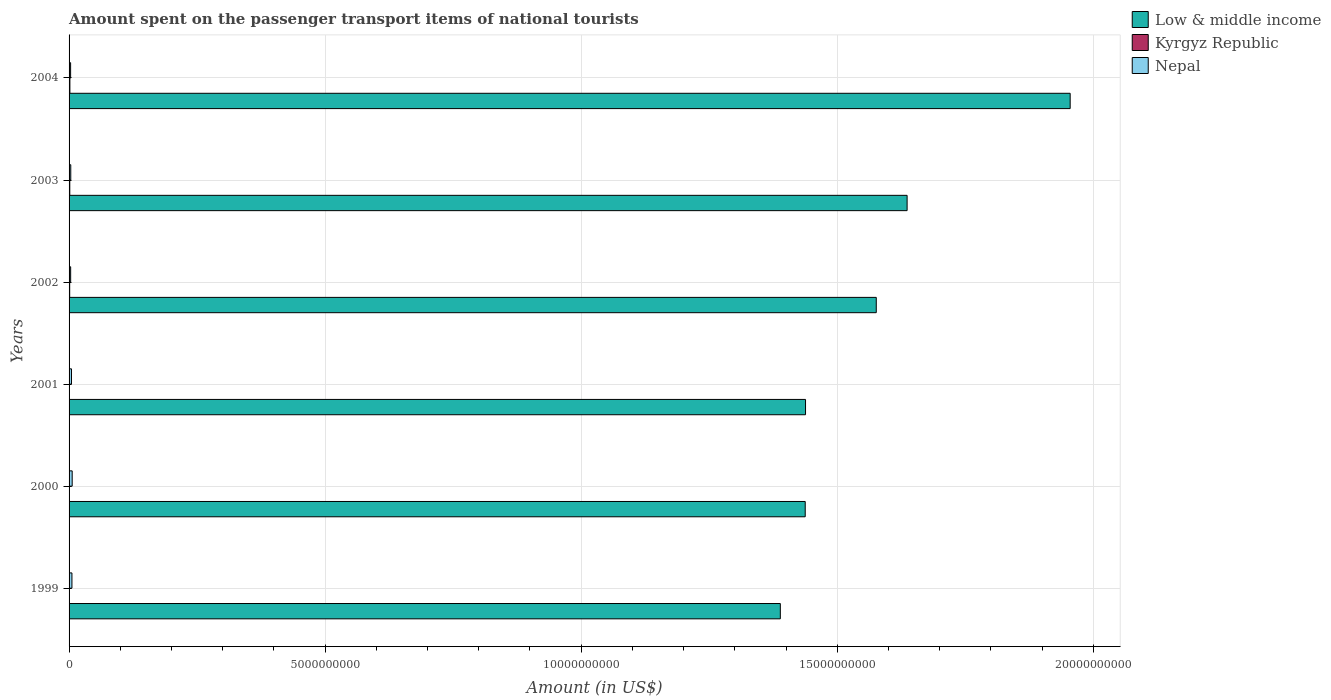How many different coloured bars are there?
Offer a very short reply. 3. How many groups of bars are there?
Provide a short and direct response. 6. Are the number of bars on each tick of the Y-axis equal?
Offer a very short reply. Yes. How many bars are there on the 6th tick from the top?
Your answer should be compact. 3. What is the amount spent on the passenger transport items of national tourists in Low & middle income in 2004?
Give a very brief answer. 1.95e+1. Across all years, what is the maximum amount spent on the passenger transport items of national tourists in Kyrgyz Republic?
Make the answer very short. 1.60e+07. Across all years, what is the minimum amount spent on the passenger transport items of national tourists in Low & middle income?
Make the answer very short. 1.39e+1. What is the total amount spent on the passenger transport items of national tourists in Nepal in the graph?
Your answer should be compact. 2.58e+08. What is the difference between the amount spent on the passenger transport items of national tourists in Kyrgyz Republic in 2000 and the amount spent on the passenger transport items of national tourists in Nepal in 2003?
Offer a terse response. -2.80e+07. What is the average amount spent on the passenger transport items of national tourists in Kyrgyz Republic per year?
Your answer should be compact. 9.83e+06. In the year 2000, what is the difference between the amount spent on the passenger transport items of national tourists in Kyrgyz Republic and amount spent on the passenger transport items of national tourists in Nepal?
Offer a terse response. -5.60e+07. What is the ratio of the amount spent on the passenger transport items of national tourists in Kyrgyz Republic in 2002 to that in 2003?
Give a very brief answer. 0.86. Is the amount spent on the passenger transport items of national tourists in Nepal in 1999 less than that in 2004?
Keep it short and to the point. No. Is the difference between the amount spent on the passenger transport items of national tourists in Kyrgyz Republic in 2002 and 2004 greater than the difference between the amount spent on the passenger transport items of national tourists in Nepal in 2002 and 2004?
Keep it short and to the point. No. What is the difference between the highest and the second highest amount spent on the passenger transport items of national tourists in Low & middle income?
Your response must be concise. 3.18e+09. In how many years, is the amount spent on the passenger transport items of national tourists in Nepal greater than the average amount spent on the passenger transport items of national tourists in Nepal taken over all years?
Your response must be concise. 3. What does the 3rd bar from the bottom in 1999 represents?
Give a very brief answer. Nepal. How many years are there in the graph?
Offer a very short reply. 6. Does the graph contain any zero values?
Provide a succinct answer. No. Does the graph contain grids?
Your answer should be compact. Yes. Where does the legend appear in the graph?
Ensure brevity in your answer.  Top right. How many legend labels are there?
Keep it short and to the point. 3. What is the title of the graph?
Provide a succinct answer. Amount spent on the passenger transport items of national tourists. Does "Chile" appear as one of the legend labels in the graph?
Ensure brevity in your answer.  No. What is the label or title of the X-axis?
Provide a succinct answer. Amount (in US$). What is the label or title of the Y-axis?
Your answer should be very brief. Years. What is the Amount (in US$) in Low & middle income in 1999?
Your answer should be very brief. 1.39e+1. What is the Amount (in US$) in Nepal in 1999?
Your answer should be very brief. 5.60e+07. What is the Amount (in US$) of Low & middle income in 2000?
Ensure brevity in your answer.  1.44e+1. What is the Amount (in US$) of Kyrgyz Republic in 2000?
Keep it short and to the point. 5.00e+06. What is the Amount (in US$) of Nepal in 2000?
Your answer should be compact. 6.10e+07. What is the Amount (in US$) in Low & middle income in 2001?
Give a very brief answer. 1.44e+1. What is the Amount (in US$) in Kyrgyz Republic in 2001?
Provide a short and direct response. 8.00e+06. What is the Amount (in US$) in Nepal in 2001?
Ensure brevity in your answer.  4.70e+07. What is the Amount (in US$) of Low & middle income in 2002?
Make the answer very short. 1.58e+1. What is the Amount (in US$) of Nepal in 2002?
Provide a short and direct response. 3.10e+07. What is the Amount (in US$) of Low & middle income in 2003?
Offer a terse response. 1.64e+1. What is the Amount (in US$) of Kyrgyz Republic in 2003?
Ensure brevity in your answer.  1.40e+07. What is the Amount (in US$) of Nepal in 2003?
Provide a short and direct response. 3.30e+07. What is the Amount (in US$) in Low & middle income in 2004?
Provide a short and direct response. 1.95e+1. What is the Amount (in US$) in Kyrgyz Republic in 2004?
Provide a succinct answer. 1.60e+07. What is the Amount (in US$) in Nepal in 2004?
Keep it short and to the point. 3.00e+07. Across all years, what is the maximum Amount (in US$) of Low & middle income?
Your answer should be compact. 1.95e+1. Across all years, what is the maximum Amount (in US$) in Kyrgyz Republic?
Your response must be concise. 1.60e+07. Across all years, what is the maximum Amount (in US$) of Nepal?
Offer a very short reply. 6.10e+07. Across all years, what is the minimum Amount (in US$) in Low & middle income?
Give a very brief answer. 1.39e+1. Across all years, what is the minimum Amount (in US$) in Nepal?
Your response must be concise. 3.00e+07. What is the total Amount (in US$) of Low & middle income in the graph?
Provide a short and direct response. 9.43e+1. What is the total Amount (in US$) of Kyrgyz Republic in the graph?
Make the answer very short. 5.90e+07. What is the total Amount (in US$) in Nepal in the graph?
Ensure brevity in your answer.  2.58e+08. What is the difference between the Amount (in US$) in Low & middle income in 1999 and that in 2000?
Provide a short and direct response. -4.86e+08. What is the difference between the Amount (in US$) in Kyrgyz Republic in 1999 and that in 2000?
Your answer should be compact. -1.00e+06. What is the difference between the Amount (in US$) of Nepal in 1999 and that in 2000?
Offer a very short reply. -5.00e+06. What is the difference between the Amount (in US$) of Low & middle income in 1999 and that in 2001?
Provide a succinct answer. -4.92e+08. What is the difference between the Amount (in US$) in Kyrgyz Republic in 1999 and that in 2001?
Give a very brief answer. -4.00e+06. What is the difference between the Amount (in US$) of Nepal in 1999 and that in 2001?
Your answer should be very brief. 9.00e+06. What is the difference between the Amount (in US$) of Low & middle income in 1999 and that in 2002?
Keep it short and to the point. -1.87e+09. What is the difference between the Amount (in US$) in Kyrgyz Republic in 1999 and that in 2002?
Your response must be concise. -8.00e+06. What is the difference between the Amount (in US$) of Nepal in 1999 and that in 2002?
Ensure brevity in your answer.  2.50e+07. What is the difference between the Amount (in US$) of Low & middle income in 1999 and that in 2003?
Your answer should be compact. -2.48e+09. What is the difference between the Amount (in US$) of Kyrgyz Republic in 1999 and that in 2003?
Give a very brief answer. -1.00e+07. What is the difference between the Amount (in US$) in Nepal in 1999 and that in 2003?
Offer a terse response. 2.30e+07. What is the difference between the Amount (in US$) of Low & middle income in 1999 and that in 2004?
Your response must be concise. -5.66e+09. What is the difference between the Amount (in US$) of Kyrgyz Republic in 1999 and that in 2004?
Keep it short and to the point. -1.20e+07. What is the difference between the Amount (in US$) of Nepal in 1999 and that in 2004?
Offer a terse response. 2.60e+07. What is the difference between the Amount (in US$) of Low & middle income in 2000 and that in 2001?
Provide a short and direct response. -5.99e+06. What is the difference between the Amount (in US$) in Kyrgyz Republic in 2000 and that in 2001?
Your response must be concise. -3.00e+06. What is the difference between the Amount (in US$) in Nepal in 2000 and that in 2001?
Make the answer very short. 1.40e+07. What is the difference between the Amount (in US$) in Low & middle income in 2000 and that in 2002?
Your answer should be very brief. -1.39e+09. What is the difference between the Amount (in US$) of Kyrgyz Republic in 2000 and that in 2002?
Your answer should be very brief. -7.00e+06. What is the difference between the Amount (in US$) in Nepal in 2000 and that in 2002?
Make the answer very short. 3.00e+07. What is the difference between the Amount (in US$) of Low & middle income in 2000 and that in 2003?
Ensure brevity in your answer.  -1.99e+09. What is the difference between the Amount (in US$) in Kyrgyz Republic in 2000 and that in 2003?
Offer a very short reply. -9.00e+06. What is the difference between the Amount (in US$) in Nepal in 2000 and that in 2003?
Offer a terse response. 2.80e+07. What is the difference between the Amount (in US$) of Low & middle income in 2000 and that in 2004?
Make the answer very short. -5.17e+09. What is the difference between the Amount (in US$) of Kyrgyz Republic in 2000 and that in 2004?
Ensure brevity in your answer.  -1.10e+07. What is the difference between the Amount (in US$) of Nepal in 2000 and that in 2004?
Provide a short and direct response. 3.10e+07. What is the difference between the Amount (in US$) of Low & middle income in 2001 and that in 2002?
Your answer should be very brief. -1.38e+09. What is the difference between the Amount (in US$) in Nepal in 2001 and that in 2002?
Provide a succinct answer. 1.60e+07. What is the difference between the Amount (in US$) of Low & middle income in 2001 and that in 2003?
Provide a succinct answer. -1.98e+09. What is the difference between the Amount (in US$) in Kyrgyz Republic in 2001 and that in 2003?
Give a very brief answer. -6.00e+06. What is the difference between the Amount (in US$) of Nepal in 2001 and that in 2003?
Keep it short and to the point. 1.40e+07. What is the difference between the Amount (in US$) in Low & middle income in 2001 and that in 2004?
Provide a succinct answer. -5.17e+09. What is the difference between the Amount (in US$) in Kyrgyz Republic in 2001 and that in 2004?
Your response must be concise. -8.00e+06. What is the difference between the Amount (in US$) of Nepal in 2001 and that in 2004?
Your answer should be compact. 1.70e+07. What is the difference between the Amount (in US$) in Low & middle income in 2002 and that in 2003?
Keep it short and to the point. -6.02e+08. What is the difference between the Amount (in US$) in Kyrgyz Republic in 2002 and that in 2003?
Provide a short and direct response. -2.00e+06. What is the difference between the Amount (in US$) of Nepal in 2002 and that in 2003?
Provide a succinct answer. -2.00e+06. What is the difference between the Amount (in US$) of Low & middle income in 2002 and that in 2004?
Ensure brevity in your answer.  -3.79e+09. What is the difference between the Amount (in US$) in Kyrgyz Republic in 2002 and that in 2004?
Offer a terse response. -4.00e+06. What is the difference between the Amount (in US$) of Low & middle income in 2003 and that in 2004?
Make the answer very short. -3.18e+09. What is the difference between the Amount (in US$) of Kyrgyz Republic in 2003 and that in 2004?
Your answer should be very brief. -2.00e+06. What is the difference between the Amount (in US$) of Low & middle income in 1999 and the Amount (in US$) of Kyrgyz Republic in 2000?
Provide a succinct answer. 1.39e+1. What is the difference between the Amount (in US$) of Low & middle income in 1999 and the Amount (in US$) of Nepal in 2000?
Ensure brevity in your answer.  1.38e+1. What is the difference between the Amount (in US$) in Kyrgyz Republic in 1999 and the Amount (in US$) in Nepal in 2000?
Make the answer very short. -5.70e+07. What is the difference between the Amount (in US$) in Low & middle income in 1999 and the Amount (in US$) in Kyrgyz Republic in 2001?
Provide a succinct answer. 1.39e+1. What is the difference between the Amount (in US$) of Low & middle income in 1999 and the Amount (in US$) of Nepal in 2001?
Give a very brief answer. 1.38e+1. What is the difference between the Amount (in US$) of Kyrgyz Republic in 1999 and the Amount (in US$) of Nepal in 2001?
Keep it short and to the point. -4.30e+07. What is the difference between the Amount (in US$) in Low & middle income in 1999 and the Amount (in US$) in Kyrgyz Republic in 2002?
Give a very brief answer. 1.39e+1. What is the difference between the Amount (in US$) in Low & middle income in 1999 and the Amount (in US$) in Nepal in 2002?
Provide a short and direct response. 1.39e+1. What is the difference between the Amount (in US$) in Kyrgyz Republic in 1999 and the Amount (in US$) in Nepal in 2002?
Your answer should be very brief. -2.70e+07. What is the difference between the Amount (in US$) of Low & middle income in 1999 and the Amount (in US$) of Kyrgyz Republic in 2003?
Provide a short and direct response. 1.39e+1. What is the difference between the Amount (in US$) in Low & middle income in 1999 and the Amount (in US$) in Nepal in 2003?
Provide a succinct answer. 1.39e+1. What is the difference between the Amount (in US$) of Kyrgyz Republic in 1999 and the Amount (in US$) of Nepal in 2003?
Your response must be concise. -2.90e+07. What is the difference between the Amount (in US$) in Low & middle income in 1999 and the Amount (in US$) in Kyrgyz Republic in 2004?
Make the answer very short. 1.39e+1. What is the difference between the Amount (in US$) in Low & middle income in 1999 and the Amount (in US$) in Nepal in 2004?
Your answer should be very brief. 1.39e+1. What is the difference between the Amount (in US$) in Kyrgyz Republic in 1999 and the Amount (in US$) in Nepal in 2004?
Provide a short and direct response. -2.60e+07. What is the difference between the Amount (in US$) of Low & middle income in 2000 and the Amount (in US$) of Kyrgyz Republic in 2001?
Your answer should be compact. 1.44e+1. What is the difference between the Amount (in US$) in Low & middle income in 2000 and the Amount (in US$) in Nepal in 2001?
Offer a terse response. 1.43e+1. What is the difference between the Amount (in US$) of Kyrgyz Republic in 2000 and the Amount (in US$) of Nepal in 2001?
Your answer should be compact. -4.20e+07. What is the difference between the Amount (in US$) of Low & middle income in 2000 and the Amount (in US$) of Kyrgyz Republic in 2002?
Your answer should be compact. 1.44e+1. What is the difference between the Amount (in US$) of Low & middle income in 2000 and the Amount (in US$) of Nepal in 2002?
Make the answer very short. 1.43e+1. What is the difference between the Amount (in US$) of Kyrgyz Republic in 2000 and the Amount (in US$) of Nepal in 2002?
Make the answer very short. -2.60e+07. What is the difference between the Amount (in US$) of Low & middle income in 2000 and the Amount (in US$) of Kyrgyz Republic in 2003?
Offer a very short reply. 1.44e+1. What is the difference between the Amount (in US$) of Low & middle income in 2000 and the Amount (in US$) of Nepal in 2003?
Make the answer very short. 1.43e+1. What is the difference between the Amount (in US$) of Kyrgyz Republic in 2000 and the Amount (in US$) of Nepal in 2003?
Your answer should be very brief. -2.80e+07. What is the difference between the Amount (in US$) of Low & middle income in 2000 and the Amount (in US$) of Kyrgyz Republic in 2004?
Provide a short and direct response. 1.44e+1. What is the difference between the Amount (in US$) in Low & middle income in 2000 and the Amount (in US$) in Nepal in 2004?
Offer a terse response. 1.43e+1. What is the difference between the Amount (in US$) in Kyrgyz Republic in 2000 and the Amount (in US$) in Nepal in 2004?
Make the answer very short. -2.50e+07. What is the difference between the Amount (in US$) of Low & middle income in 2001 and the Amount (in US$) of Kyrgyz Republic in 2002?
Provide a succinct answer. 1.44e+1. What is the difference between the Amount (in US$) in Low & middle income in 2001 and the Amount (in US$) in Nepal in 2002?
Your response must be concise. 1.43e+1. What is the difference between the Amount (in US$) in Kyrgyz Republic in 2001 and the Amount (in US$) in Nepal in 2002?
Your response must be concise. -2.30e+07. What is the difference between the Amount (in US$) of Low & middle income in 2001 and the Amount (in US$) of Kyrgyz Republic in 2003?
Provide a succinct answer. 1.44e+1. What is the difference between the Amount (in US$) in Low & middle income in 2001 and the Amount (in US$) in Nepal in 2003?
Provide a succinct answer. 1.43e+1. What is the difference between the Amount (in US$) of Kyrgyz Republic in 2001 and the Amount (in US$) of Nepal in 2003?
Your answer should be compact. -2.50e+07. What is the difference between the Amount (in US$) in Low & middle income in 2001 and the Amount (in US$) in Kyrgyz Republic in 2004?
Make the answer very short. 1.44e+1. What is the difference between the Amount (in US$) of Low & middle income in 2001 and the Amount (in US$) of Nepal in 2004?
Provide a short and direct response. 1.44e+1. What is the difference between the Amount (in US$) of Kyrgyz Republic in 2001 and the Amount (in US$) of Nepal in 2004?
Make the answer very short. -2.20e+07. What is the difference between the Amount (in US$) of Low & middle income in 2002 and the Amount (in US$) of Kyrgyz Republic in 2003?
Your answer should be compact. 1.57e+1. What is the difference between the Amount (in US$) in Low & middle income in 2002 and the Amount (in US$) in Nepal in 2003?
Offer a very short reply. 1.57e+1. What is the difference between the Amount (in US$) in Kyrgyz Republic in 2002 and the Amount (in US$) in Nepal in 2003?
Make the answer very short. -2.10e+07. What is the difference between the Amount (in US$) of Low & middle income in 2002 and the Amount (in US$) of Kyrgyz Republic in 2004?
Make the answer very short. 1.57e+1. What is the difference between the Amount (in US$) in Low & middle income in 2002 and the Amount (in US$) in Nepal in 2004?
Ensure brevity in your answer.  1.57e+1. What is the difference between the Amount (in US$) of Kyrgyz Republic in 2002 and the Amount (in US$) of Nepal in 2004?
Give a very brief answer. -1.80e+07. What is the difference between the Amount (in US$) in Low & middle income in 2003 and the Amount (in US$) in Kyrgyz Republic in 2004?
Ensure brevity in your answer.  1.63e+1. What is the difference between the Amount (in US$) in Low & middle income in 2003 and the Amount (in US$) in Nepal in 2004?
Provide a short and direct response. 1.63e+1. What is the difference between the Amount (in US$) in Kyrgyz Republic in 2003 and the Amount (in US$) in Nepal in 2004?
Your answer should be compact. -1.60e+07. What is the average Amount (in US$) in Low & middle income per year?
Make the answer very short. 1.57e+1. What is the average Amount (in US$) of Kyrgyz Republic per year?
Give a very brief answer. 9.83e+06. What is the average Amount (in US$) in Nepal per year?
Your response must be concise. 4.30e+07. In the year 1999, what is the difference between the Amount (in US$) in Low & middle income and Amount (in US$) in Kyrgyz Republic?
Make the answer very short. 1.39e+1. In the year 1999, what is the difference between the Amount (in US$) in Low & middle income and Amount (in US$) in Nepal?
Ensure brevity in your answer.  1.38e+1. In the year 1999, what is the difference between the Amount (in US$) of Kyrgyz Republic and Amount (in US$) of Nepal?
Your response must be concise. -5.20e+07. In the year 2000, what is the difference between the Amount (in US$) in Low & middle income and Amount (in US$) in Kyrgyz Republic?
Offer a very short reply. 1.44e+1. In the year 2000, what is the difference between the Amount (in US$) in Low & middle income and Amount (in US$) in Nepal?
Offer a terse response. 1.43e+1. In the year 2000, what is the difference between the Amount (in US$) of Kyrgyz Republic and Amount (in US$) of Nepal?
Your answer should be compact. -5.60e+07. In the year 2001, what is the difference between the Amount (in US$) of Low & middle income and Amount (in US$) of Kyrgyz Republic?
Make the answer very short. 1.44e+1. In the year 2001, what is the difference between the Amount (in US$) of Low & middle income and Amount (in US$) of Nepal?
Offer a terse response. 1.43e+1. In the year 2001, what is the difference between the Amount (in US$) of Kyrgyz Republic and Amount (in US$) of Nepal?
Your answer should be compact. -3.90e+07. In the year 2002, what is the difference between the Amount (in US$) in Low & middle income and Amount (in US$) in Kyrgyz Republic?
Provide a succinct answer. 1.57e+1. In the year 2002, what is the difference between the Amount (in US$) in Low & middle income and Amount (in US$) in Nepal?
Your response must be concise. 1.57e+1. In the year 2002, what is the difference between the Amount (in US$) in Kyrgyz Republic and Amount (in US$) in Nepal?
Provide a succinct answer. -1.90e+07. In the year 2003, what is the difference between the Amount (in US$) in Low & middle income and Amount (in US$) in Kyrgyz Republic?
Provide a short and direct response. 1.64e+1. In the year 2003, what is the difference between the Amount (in US$) of Low & middle income and Amount (in US$) of Nepal?
Your response must be concise. 1.63e+1. In the year 2003, what is the difference between the Amount (in US$) in Kyrgyz Republic and Amount (in US$) in Nepal?
Give a very brief answer. -1.90e+07. In the year 2004, what is the difference between the Amount (in US$) in Low & middle income and Amount (in US$) in Kyrgyz Republic?
Offer a very short reply. 1.95e+1. In the year 2004, what is the difference between the Amount (in US$) in Low & middle income and Amount (in US$) in Nepal?
Give a very brief answer. 1.95e+1. In the year 2004, what is the difference between the Amount (in US$) in Kyrgyz Republic and Amount (in US$) in Nepal?
Offer a terse response. -1.40e+07. What is the ratio of the Amount (in US$) in Low & middle income in 1999 to that in 2000?
Offer a very short reply. 0.97. What is the ratio of the Amount (in US$) of Kyrgyz Republic in 1999 to that in 2000?
Offer a very short reply. 0.8. What is the ratio of the Amount (in US$) in Nepal in 1999 to that in 2000?
Provide a succinct answer. 0.92. What is the ratio of the Amount (in US$) of Low & middle income in 1999 to that in 2001?
Your answer should be compact. 0.97. What is the ratio of the Amount (in US$) of Kyrgyz Republic in 1999 to that in 2001?
Your answer should be compact. 0.5. What is the ratio of the Amount (in US$) of Nepal in 1999 to that in 2001?
Make the answer very short. 1.19. What is the ratio of the Amount (in US$) of Low & middle income in 1999 to that in 2002?
Your response must be concise. 0.88. What is the ratio of the Amount (in US$) of Nepal in 1999 to that in 2002?
Provide a short and direct response. 1.81. What is the ratio of the Amount (in US$) of Low & middle income in 1999 to that in 2003?
Offer a terse response. 0.85. What is the ratio of the Amount (in US$) of Kyrgyz Republic in 1999 to that in 2003?
Offer a very short reply. 0.29. What is the ratio of the Amount (in US$) of Nepal in 1999 to that in 2003?
Offer a very short reply. 1.7. What is the ratio of the Amount (in US$) of Low & middle income in 1999 to that in 2004?
Provide a succinct answer. 0.71. What is the ratio of the Amount (in US$) in Kyrgyz Republic in 1999 to that in 2004?
Offer a very short reply. 0.25. What is the ratio of the Amount (in US$) in Nepal in 1999 to that in 2004?
Your answer should be compact. 1.87. What is the ratio of the Amount (in US$) of Low & middle income in 2000 to that in 2001?
Make the answer very short. 1. What is the ratio of the Amount (in US$) in Kyrgyz Republic in 2000 to that in 2001?
Provide a succinct answer. 0.62. What is the ratio of the Amount (in US$) of Nepal in 2000 to that in 2001?
Offer a very short reply. 1.3. What is the ratio of the Amount (in US$) of Low & middle income in 2000 to that in 2002?
Your answer should be compact. 0.91. What is the ratio of the Amount (in US$) in Kyrgyz Republic in 2000 to that in 2002?
Make the answer very short. 0.42. What is the ratio of the Amount (in US$) in Nepal in 2000 to that in 2002?
Offer a very short reply. 1.97. What is the ratio of the Amount (in US$) of Low & middle income in 2000 to that in 2003?
Make the answer very short. 0.88. What is the ratio of the Amount (in US$) in Kyrgyz Republic in 2000 to that in 2003?
Give a very brief answer. 0.36. What is the ratio of the Amount (in US$) of Nepal in 2000 to that in 2003?
Offer a very short reply. 1.85. What is the ratio of the Amount (in US$) in Low & middle income in 2000 to that in 2004?
Keep it short and to the point. 0.74. What is the ratio of the Amount (in US$) in Kyrgyz Republic in 2000 to that in 2004?
Give a very brief answer. 0.31. What is the ratio of the Amount (in US$) of Nepal in 2000 to that in 2004?
Offer a very short reply. 2.03. What is the ratio of the Amount (in US$) in Low & middle income in 2001 to that in 2002?
Provide a succinct answer. 0.91. What is the ratio of the Amount (in US$) in Kyrgyz Republic in 2001 to that in 2002?
Make the answer very short. 0.67. What is the ratio of the Amount (in US$) of Nepal in 2001 to that in 2002?
Provide a succinct answer. 1.52. What is the ratio of the Amount (in US$) in Low & middle income in 2001 to that in 2003?
Make the answer very short. 0.88. What is the ratio of the Amount (in US$) of Kyrgyz Republic in 2001 to that in 2003?
Your response must be concise. 0.57. What is the ratio of the Amount (in US$) in Nepal in 2001 to that in 2003?
Make the answer very short. 1.42. What is the ratio of the Amount (in US$) in Low & middle income in 2001 to that in 2004?
Offer a terse response. 0.74. What is the ratio of the Amount (in US$) in Kyrgyz Republic in 2001 to that in 2004?
Provide a succinct answer. 0.5. What is the ratio of the Amount (in US$) of Nepal in 2001 to that in 2004?
Offer a terse response. 1.57. What is the ratio of the Amount (in US$) in Low & middle income in 2002 to that in 2003?
Your answer should be compact. 0.96. What is the ratio of the Amount (in US$) in Nepal in 2002 to that in 2003?
Keep it short and to the point. 0.94. What is the ratio of the Amount (in US$) of Low & middle income in 2002 to that in 2004?
Make the answer very short. 0.81. What is the ratio of the Amount (in US$) of Kyrgyz Republic in 2002 to that in 2004?
Provide a short and direct response. 0.75. What is the ratio of the Amount (in US$) of Low & middle income in 2003 to that in 2004?
Your response must be concise. 0.84. What is the difference between the highest and the second highest Amount (in US$) of Low & middle income?
Make the answer very short. 3.18e+09. What is the difference between the highest and the second highest Amount (in US$) of Kyrgyz Republic?
Keep it short and to the point. 2.00e+06. What is the difference between the highest and the lowest Amount (in US$) in Low & middle income?
Your answer should be compact. 5.66e+09. What is the difference between the highest and the lowest Amount (in US$) in Kyrgyz Republic?
Ensure brevity in your answer.  1.20e+07. What is the difference between the highest and the lowest Amount (in US$) of Nepal?
Ensure brevity in your answer.  3.10e+07. 